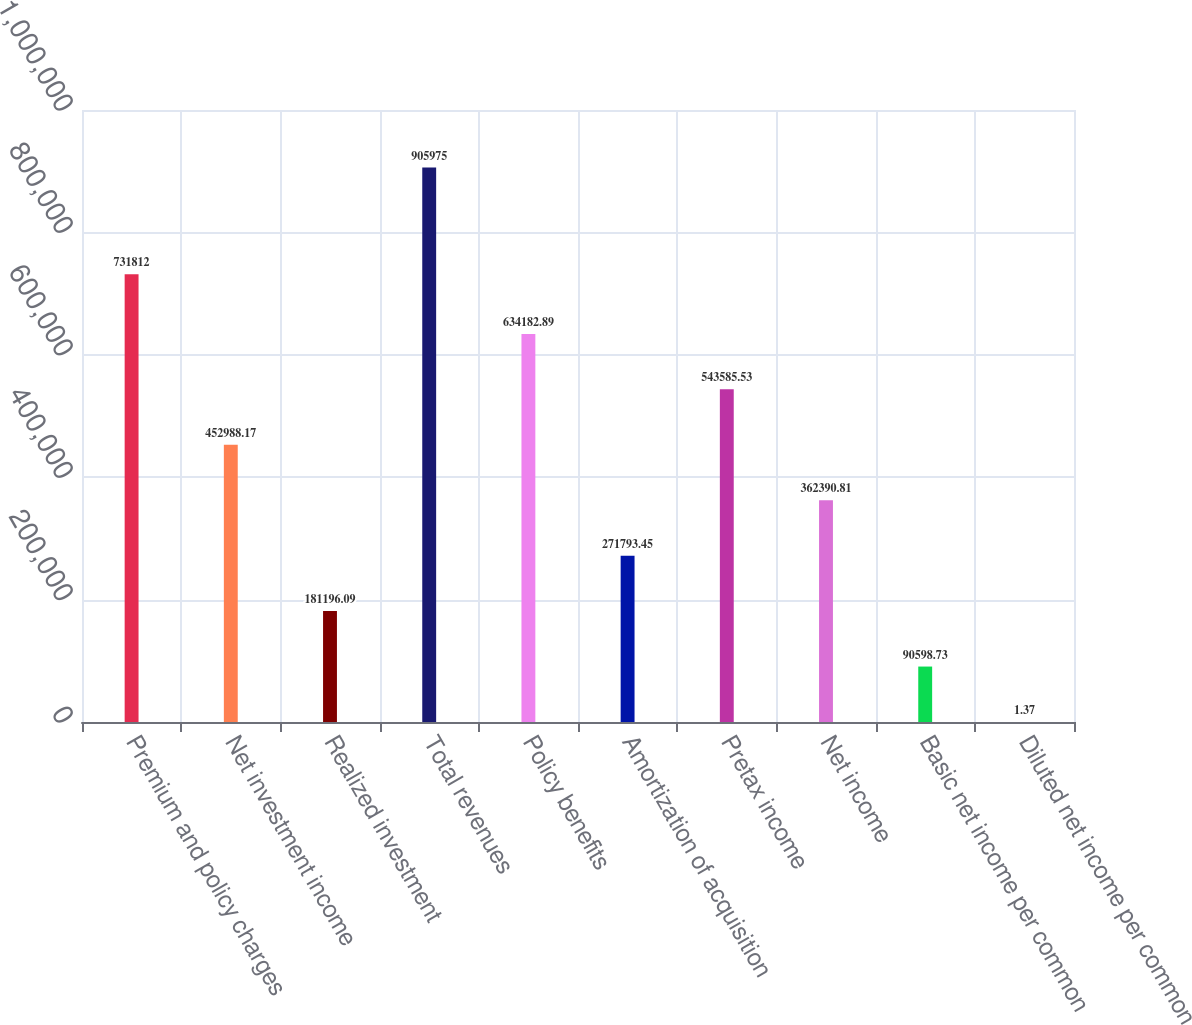Convert chart to OTSL. <chart><loc_0><loc_0><loc_500><loc_500><bar_chart><fcel>Premium and policy charges<fcel>Net investment income<fcel>Realized investment<fcel>Total revenues<fcel>Policy benefits<fcel>Amortization of acquisition<fcel>Pretax income<fcel>Net income<fcel>Basic net income per common<fcel>Diluted net income per common<nl><fcel>731812<fcel>452988<fcel>181196<fcel>905975<fcel>634183<fcel>271793<fcel>543586<fcel>362391<fcel>90598.7<fcel>1.37<nl></chart> 